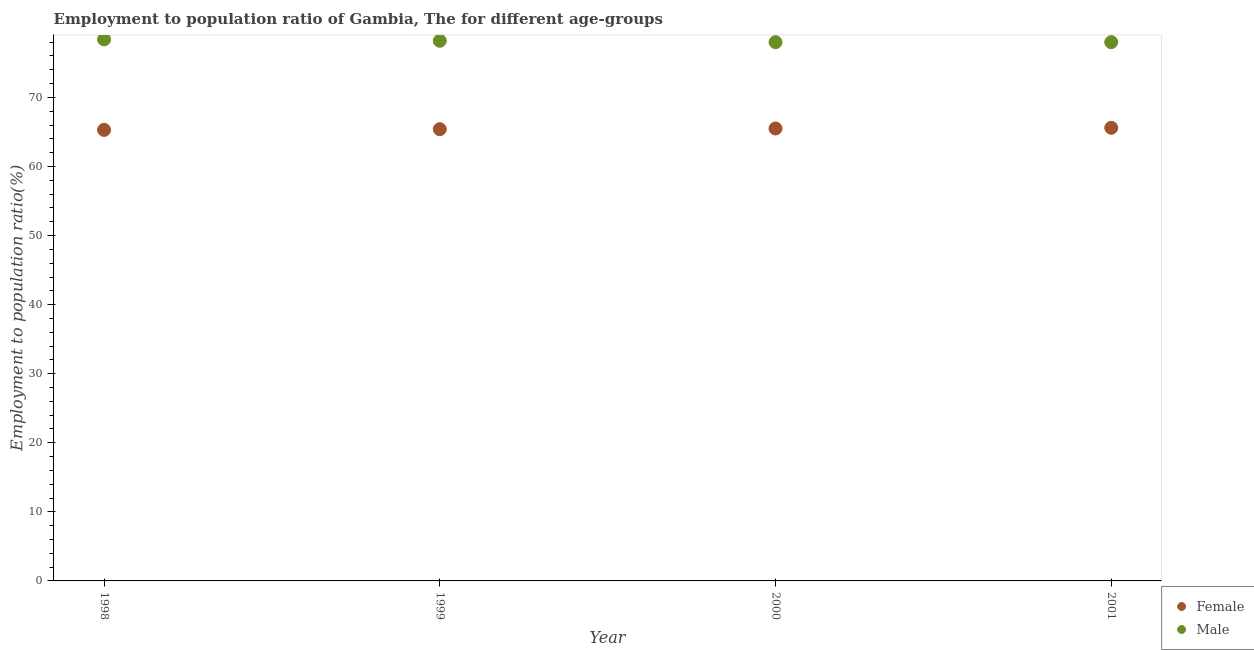How many different coloured dotlines are there?
Keep it short and to the point. 2. What is the employment to population ratio(female) in 2001?
Ensure brevity in your answer.  65.6. Across all years, what is the maximum employment to population ratio(male)?
Make the answer very short. 78.4. Across all years, what is the minimum employment to population ratio(female)?
Provide a succinct answer. 65.3. In which year was the employment to population ratio(female) minimum?
Keep it short and to the point. 1998. What is the total employment to population ratio(male) in the graph?
Your answer should be very brief. 312.6. What is the difference between the employment to population ratio(male) in 1999 and that in 2000?
Keep it short and to the point. 0.2. What is the difference between the employment to population ratio(female) in 2001 and the employment to population ratio(male) in 1999?
Your answer should be compact. -12.6. What is the average employment to population ratio(male) per year?
Make the answer very short. 78.15. In the year 1998, what is the difference between the employment to population ratio(female) and employment to population ratio(male)?
Give a very brief answer. -13.1. In how many years, is the employment to population ratio(female) greater than 34 %?
Make the answer very short. 4. What is the ratio of the employment to population ratio(male) in 1999 to that in 2001?
Make the answer very short. 1. Is the employment to population ratio(female) in 1998 less than that in 2000?
Your answer should be very brief. Yes. Is the difference between the employment to population ratio(female) in 1998 and 2001 greater than the difference between the employment to population ratio(male) in 1998 and 2001?
Give a very brief answer. No. What is the difference between the highest and the second highest employment to population ratio(female)?
Keep it short and to the point. 0.1. What is the difference between the highest and the lowest employment to population ratio(female)?
Keep it short and to the point. 0.3. Is the employment to population ratio(female) strictly less than the employment to population ratio(male) over the years?
Your answer should be very brief. Yes. How many dotlines are there?
Keep it short and to the point. 2. Does the graph contain grids?
Your response must be concise. No. How are the legend labels stacked?
Provide a short and direct response. Vertical. What is the title of the graph?
Offer a terse response. Employment to population ratio of Gambia, The for different age-groups. Does "Public funds" appear as one of the legend labels in the graph?
Ensure brevity in your answer.  No. What is the label or title of the X-axis?
Make the answer very short. Year. What is the Employment to population ratio(%) in Female in 1998?
Provide a succinct answer. 65.3. What is the Employment to population ratio(%) of Male in 1998?
Your response must be concise. 78.4. What is the Employment to population ratio(%) in Female in 1999?
Provide a succinct answer. 65.4. What is the Employment to population ratio(%) of Male in 1999?
Your response must be concise. 78.2. What is the Employment to population ratio(%) of Female in 2000?
Your response must be concise. 65.5. What is the Employment to population ratio(%) of Male in 2000?
Your answer should be very brief. 78. What is the Employment to population ratio(%) of Female in 2001?
Keep it short and to the point. 65.6. What is the Employment to population ratio(%) of Male in 2001?
Your response must be concise. 78. Across all years, what is the maximum Employment to population ratio(%) in Female?
Make the answer very short. 65.6. Across all years, what is the maximum Employment to population ratio(%) of Male?
Give a very brief answer. 78.4. Across all years, what is the minimum Employment to population ratio(%) of Female?
Ensure brevity in your answer.  65.3. What is the total Employment to population ratio(%) in Female in the graph?
Offer a very short reply. 261.8. What is the total Employment to population ratio(%) in Male in the graph?
Provide a succinct answer. 312.6. What is the difference between the Employment to population ratio(%) in Female in 1998 and that in 2000?
Your response must be concise. -0.2. What is the difference between the Employment to population ratio(%) in Male in 1998 and that in 2001?
Your answer should be very brief. 0.4. What is the difference between the Employment to population ratio(%) in Female in 1999 and that in 2000?
Give a very brief answer. -0.1. What is the difference between the Employment to population ratio(%) of Male in 1999 and that in 2000?
Keep it short and to the point. 0.2. What is the difference between the Employment to population ratio(%) in Female in 1999 and that in 2001?
Ensure brevity in your answer.  -0.2. What is the difference between the Employment to population ratio(%) of Male in 1999 and that in 2001?
Offer a very short reply. 0.2. What is the difference between the Employment to population ratio(%) in Female in 2000 and that in 2001?
Provide a succinct answer. -0.1. What is the difference between the Employment to population ratio(%) in Male in 2000 and that in 2001?
Provide a succinct answer. 0. What is the difference between the Employment to population ratio(%) in Female in 1998 and the Employment to population ratio(%) in Male in 2001?
Offer a terse response. -12.7. What is the difference between the Employment to population ratio(%) of Female in 1999 and the Employment to population ratio(%) of Male in 2001?
Provide a succinct answer. -12.6. What is the difference between the Employment to population ratio(%) in Female in 2000 and the Employment to population ratio(%) in Male in 2001?
Your answer should be compact. -12.5. What is the average Employment to population ratio(%) in Female per year?
Keep it short and to the point. 65.45. What is the average Employment to population ratio(%) of Male per year?
Give a very brief answer. 78.15. In the year 1999, what is the difference between the Employment to population ratio(%) of Female and Employment to population ratio(%) of Male?
Offer a terse response. -12.8. In the year 2001, what is the difference between the Employment to population ratio(%) in Female and Employment to population ratio(%) in Male?
Provide a short and direct response. -12.4. What is the ratio of the Employment to population ratio(%) in Female in 1998 to that in 1999?
Offer a very short reply. 1. What is the ratio of the Employment to population ratio(%) of Male in 1998 to that in 1999?
Your answer should be very brief. 1. What is the ratio of the Employment to population ratio(%) of Male in 1998 to that in 2000?
Your answer should be compact. 1.01. What is the ratio of the Employment to population ratio(%) of Male in 1999 to that in 2000?
Provide a short and direct response. 1. What is the ratio of the Employment to population ratio(%) in Male in 1999 to that in 2001?
Give a very brief answer. 1. What is the difference between the highest and the lowest Employment to population ratio(%) in Female?
Make the answer very short. 0.3. What is the difference between the highest and the lowest Employment to population ratio(%) of Male?
Your answer should be compact. 0.4. 